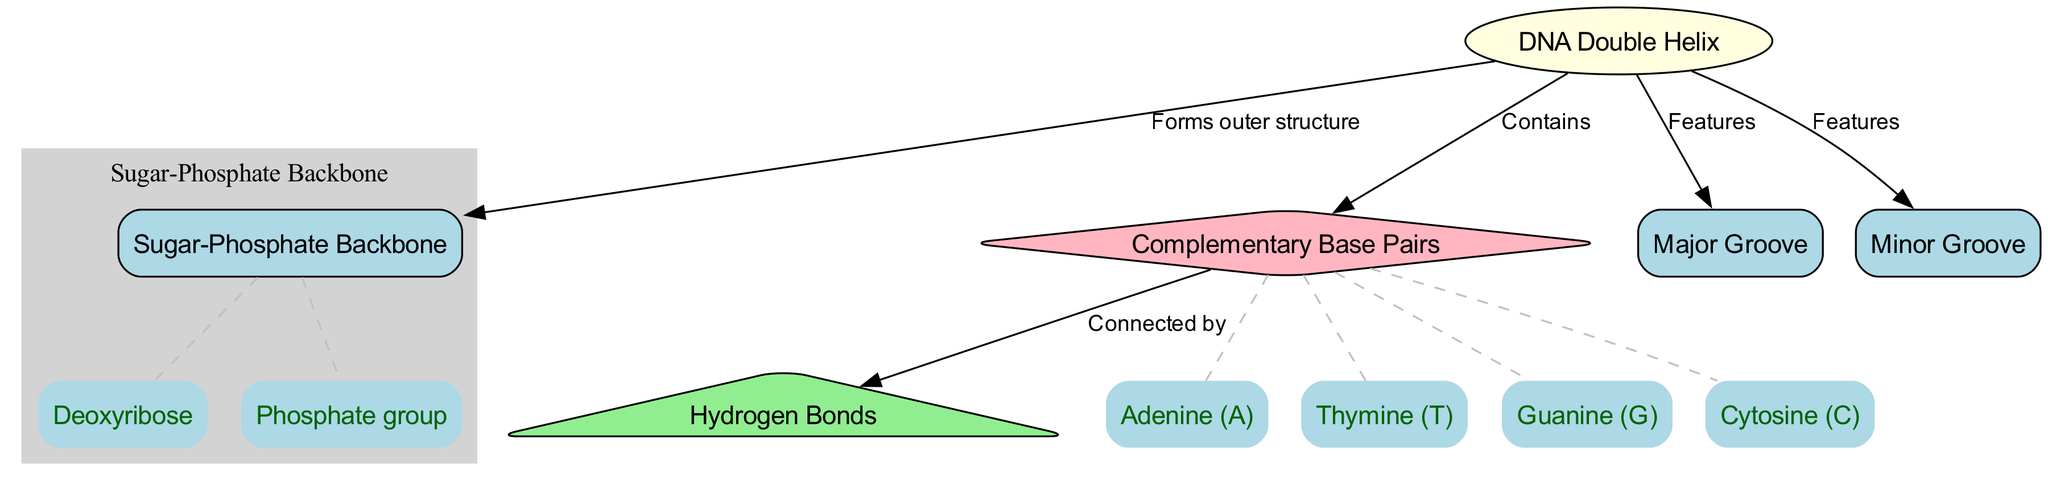What is the central structure of the DNA represented in the diagram? The diagram highlights the main structural element labeled as "DNA Double Helix," which indicates the overall form of DNA. This identification is made by looking for the main node in the center of the diagram.
Answer: DNA Double Helix How many types of base pairs are indicated in the diagram? The diagram shows four labels under the section for "Complementary Base Pairs," specifically Adenine, Thymine, Guanine, and Cytosine. This is determined by counting the labeled components directly associated with that section.
Answer: Four What connects the complementary base pairs in the DNA structure? The diagram points out "Hydrogen Bonds" as the connections between the base pairs. This can be inferred from the edge labeled "Connected by" that links the "Base Pairs" node to the "Hydrogen Bonds" node.
Answer: Hydrogen Bonds What is the role of the sugar-phosphate backbone in the DNA structure? The diagram indicates that the "Sugar-Phosphate Backbone" "Forms outer structure" around the DNA, signifying its function in maintaining the structure of the helix. This relationship is established via edges connecting "DNA Double Helix" with "Sugar-Phosphate Backbone."
Answer: Forms outer structure Which groove is highlighted as larger in the DNA structure? The label "Major Groove" specifically identifies the larger groove in the helical structure of DNA. This distinction can be found directly in the diagram through the corresponding edge from the "DNA Double Helix" node.
Answer: Major Groove What elements constitute the sugar-phosphate backbone? The diagram lists "Deoxyribose" and "Phosphate group" as components of the "Sugar-Phosphate Backbone." This detail is seen in the labels within the subgraph that groups these elements under the backbone node.
Answer: Deoxyribose, Phosphate group What feature is shared by both the major and minor grooves in the DNA structure? Both grooves are indicated as features of the "DNA Double Helix," as seen from edges connecting them directly to the main DNA structure node, illustrating they are parts of the overall architecture.
Answer: Features How are base pairs structured in terms of their complementary nature? The diagram suggests that base pairs consist of specific complementary pairs that follow the A-T and G-C pairing rules, highlighted through the labels directly under "Complementary Base Pairs." This observation reflects an essential concept of DNA structure based on pairing rules.
Answer: A-T, G-C pairing 